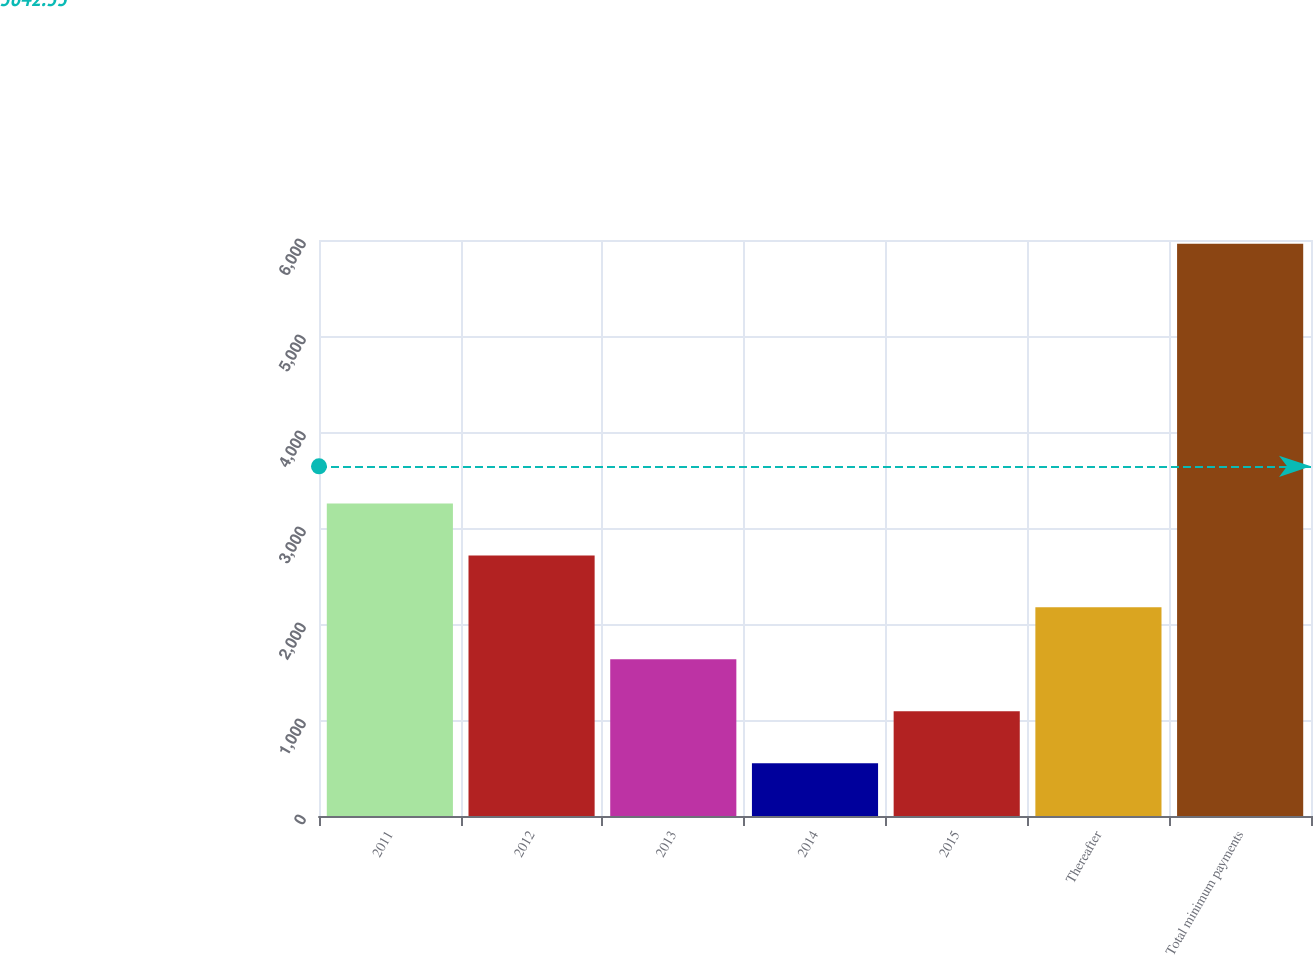Convert chart. <chart><loc_0><loc_0><loc_500><loc_500><bar_chart><fcel>2011<fcel>2012<fcel>2013<fcel>2014<fcel>2015<fcel>Thereafter<fcel>Total minimum payments<nl><fcel>3256<fcel>2714.8<fcel>1632.4<fcel>550<fcel>1091.2<fcel>2173.6<fcel>5962<nl></chart> 